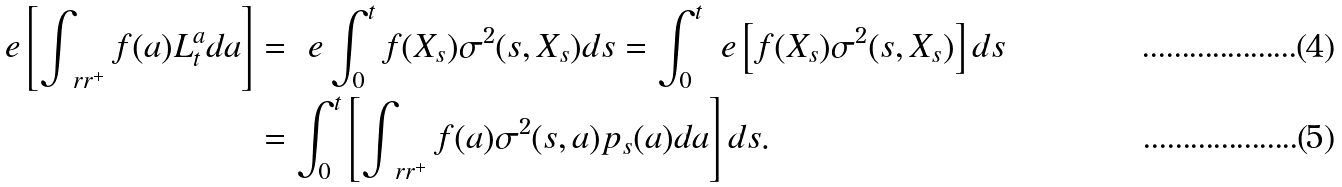<formula> <loc_0><loc_0><loc_500><loc_500>\ e \left [ \int _ { \ r r ^ { + } } f ( a ) L _ { t } ^ { a } d a \right ] & = \ e \int _ { 0 } ^ { t } f ( X _ { s } ) \sigma ^ { 2 } ( s , X _ { s } ) d s = \int _ { 0 } ^ { t } \ e \left [ f ( X _ { s } ) \sigma ^ { 2 } ( s , X _ { s } ) \right ] d s \\ & = \int _ { 0 } ^ { t } \left [ \int _ { \ r r ^ { + } } f ( a ) \sigma ^ { 2 } ( s , a ) p _ { s } ( a ) d a \right ] d s .</formula> 